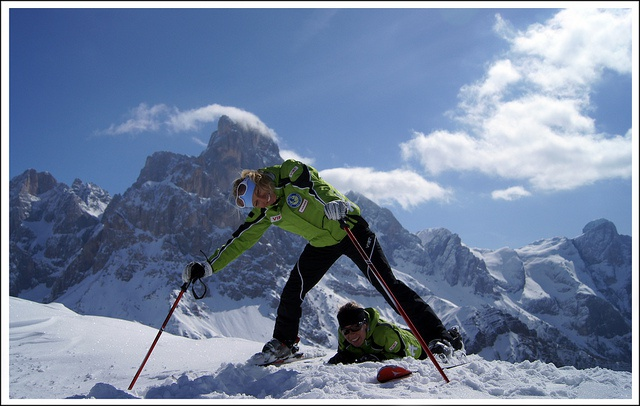Describe the objects in this image and their specific colors. I can see people in black, darkgreen, and gray tones, people in black, darkgreen, and gray tones, and skis in black, maroon, gray, and darkgray tones in this image. 